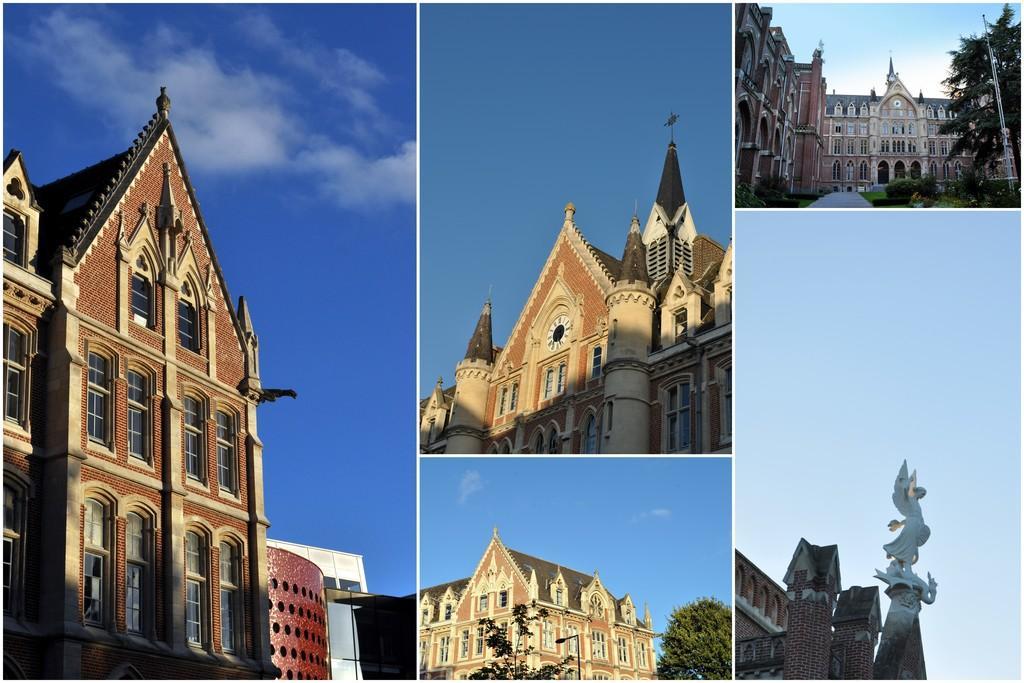How would you summarize this image in a sentence or two? It is the collage of five images. On the left side image there is a building. On the right side bottom there is a statue in front of the building. In the middle there are two buildings in two images. 